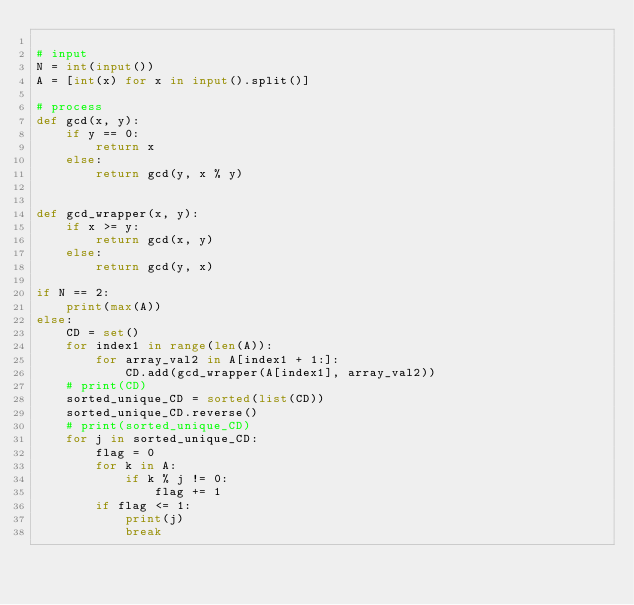<code> <loc_0><loc_0><loc_500><loc_500><_Python_>
# input
N = int(input())
A = [int(x) for x in input().split()]

# process
def gcd(x, y):
    if y == 0:
        return x
    else:
        return gcd(y, x % y)


def gcd_wrapper(x, y):
    if x >= y:
        return gcd(x, y)
    else:
        return gcd(y, x)

if N == 2:
    print(max(A))
else:
    CD = set()
    for index1 in range(len(A)):
        for array_val2 in A[index1 + 1:]:
            CD.add(gcd_wrapper(A[index1], array_val2))
    # print(CD)
    sorted_unique_CD = sorted(list(CD))
    sorted_unique_CD.reverse()
    # print(sorted_unique_CD)
    for j in sorted_unique_CD:
        flag = 0
        for k in A:
            if k % j != 0:
                flag += 1
        if flag <= 1:
            print(j)
            break
</code> 